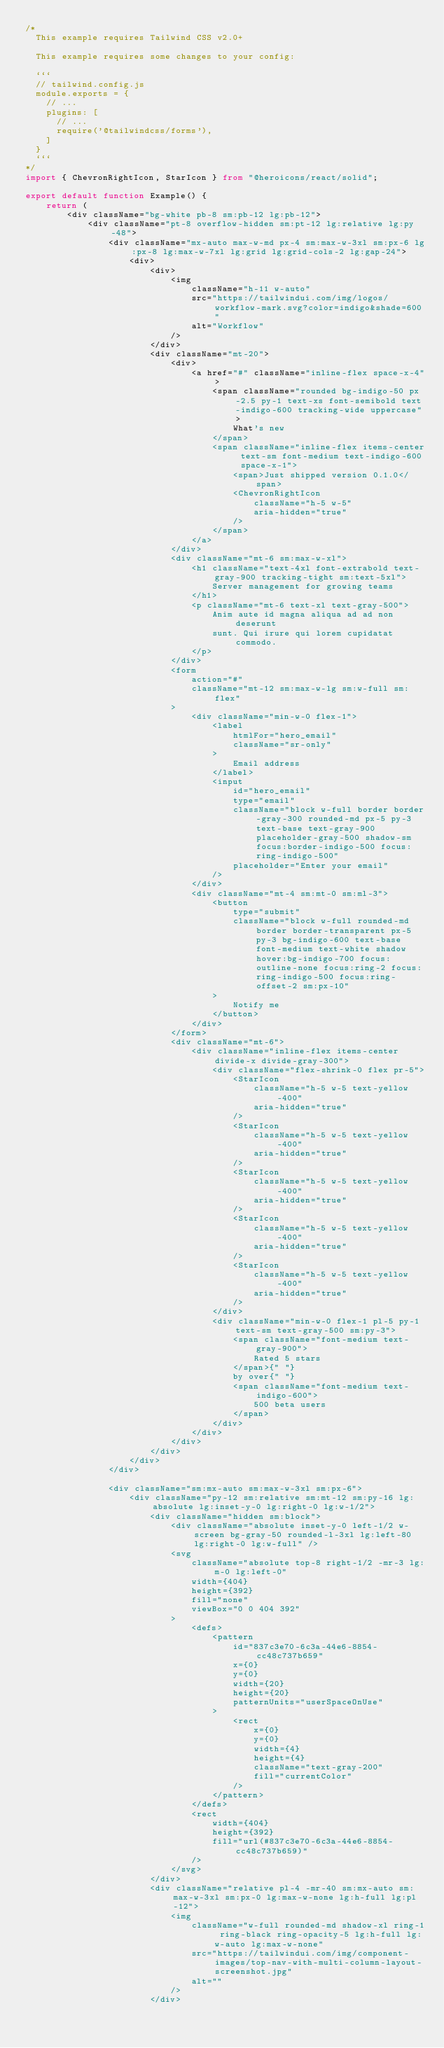Convert code to text. <code><loc_0><loc_0><loc_500><loc_500><_TypeScript_>/*
  This example requires Tailwind CSS v2.0+ 
  
  This example requires some changes to your config:
  
  ```
  // tailwind.config.js
  module.exports = {
    // ...
    plugins: [
      // ...
      require('@tailwindcss/forms'),
    ]
  }
  ```
*/
import { ChevronRightIcon, StarIcon } from "@heroicons/react/solid";

export default function Example() {
    return (
        <div className="bg-white pb-8 sm:pb-12 lg:pb-12">
            <div className="pt-8 overflow-hidden sm:pt-12 lg:relative lg:py-48">
                <div className="mx-auto max-w-md px-4 sm:max-w-3xl sm:px-6 lg:px-8 lg:max-w-7xl lg:grid lg:grid-cols-2 lg:gap-24">
                    <div>
                        <div>
                            <img
                                className="h-11 w-auto"
                                src="https://tailwindui.com/img/logos/workflow-mark.svg?color=indigo&shade=600"
                                alt="Workflow"
                            />
                        </div>
                        <div className="mt-20">
                            <div>
                                <a href="#" className="inline-flex space-x-4">
                                    <span className="rounded bg-indigo-50 px-2.5 py-1 text-xs font-semibold text-indigo-600 tracking-wide uppercase">
                                        What's new
                                    </span>
                                    <span className="inline-flex items-center text-sm font-medium text-indigo-600 space-x-1">
                                        <span>Just shipped version 0.1.0</span>
                                        <ChevronRightIcon
                                            className="h-5 w-5"
                                            aria-hidden="true"
                                        />
                                    </span>
                                </a>
                            </div>
                            <div className="mt-6 sm:max-w-xl">
                                <h1 className="text-4xl font-extrabold text-gray-900 tracking-tight sm:text-5xl">
                                    Server management for growing teams
                                </h1>
                                <p className="mt-6 text-xl text-gray-500">
                                    Anim aute id magna aliqua ad ad non deserunt
                                    sunt. Qui irure qui lorem cupidatat commodo.
                                </p>
                            </div>
                            <form
                                action="#"
                                className="mt-12 sm:max-w-lg sm:w-full sm:flex"
                            >
                                <div className="min-w-0 flex-1">
                                    <label
                                        htmlFor="hero_email"
                                        className="sr-only"
                                    >
                                        Email address
                                    </label>
                                    <input
                                        id="hero_email"
                                        type="email"
                                        className="block w-full border border-gray-300 rounded-md px-5 py-3 text-base text-gray-900 placeholder-gray-500 shadow-sm focus:border-indigo-500 focus:ring-indigo-500"
                                        placeholder="Enter your email"
                                    />
                                </div>
                                <div className="mt-4 sm:mt-0 sm:ml-3">
                                    <button
                                        type="submit"
                                        className="block w-full rounded-md border border-transparent px-5 py-3 bg-indigo-600 text-base font-medium text-white shadow hover:bg-indigo-700 focus:outline-none focus:ring-2 focus:ring-indigo-500 focus:ring-offset-2 sm:px-10"
                                    >
                                        Notify me
                                    </button>
                                </div>
                            </form>
                            <div className="mt-6">
                                <div className="inline-flex items-center divide-x divide-gray-300">
                                    <div className="flex-shrink-0 flex pr-5">
                                        <StarIcon
                                            className="h-5 w-5 text-yellow-400"
                                            aria-hidden="true"
                                        />
                                        <StarIcon
                                            className="h-5 w-5 text-yellow-400"
                                            aria-hidden="true"
                                        />
                                        <StarIcon
                                            className="h-5 w-5 text-yellow-400"
                                            aria-hidden="true"
                                        />
                                        <StarIcon
                                            className="h-5 w-5 text-yellow-400"
                                            aria-hidden="true"
                                        />
                                        <StarIcon
                                            className="h-5 w-5 text-yellow-400"
                                            aria-hidden="true"
                                        />
                                    </div>
                                    <div className="min-w-0 flex-1 pl-5 py-1 text-sm text-gray-500 sm:py-3">
                                        <span className="font-medium text-gray-900">
                                            Rated 5 stars
                                        </span>{" "}
                                        by over{" "}
                                        <span className="font-medium text-indigo-600">
                                            500 beta users
                                        </span>
                                    </div>
                                </div>
                            </div>
                        </div>
                    </div>
                </div>

                <div className="sm:mx-auto sm:max-w-3xl sm:px-6">
                    <div className="py-12 sm:relative sm:mt-12 sm:py-16 lg:absolute lg:inset-y-0 lg:right-0 lg:w-1/2">
                        <div className="hidden sm:block">
                            <div className="absolute inset-y-0 left-1/2 w-screen bg-gray-50 rounded-l-3xl lg:left-80 lg:right-0 lg:w-full" />
                            <svg
                                className="absolute top-8 right-1/2 -mr-3 lg:m-0 lg:left-0"
                                width={404}
                                height={392}
                                fill="none"
                                viewBox="0 0 404 392"
                            >
                                <defs>
                                    <pattern
                                        id="837c3e70-6c3a-44e6-8854-cc48c737b659"
                                        x={0}
                                        y={0}
                                        width={20}
                                        height={20}
                                        patternUnits="userSpaceOnUse"
                                    >
                                        <rect
                                            x={0}
                                            y={0}
                                            width={4}
                                            height={4}
                                            className="text-gray-200"
                                            fill="currentColor"
                                        />
                                    </pattern>
                                </defs>
                                <rect
                                    width={404}
                                    height={392}
                                    fill="url(#837c3e70-6c3a-44e6-8854-cc48c737b659)"
                                />
                            </svg>
                        </div>
                        <div className="relative pl-4 -mr-40 sm:mx-auto sm:max-w-3xl sm:px-0 lg:max-w-none lg:h-full lg:pl-12">
                            <img
                                className="w-full rounded-md shadow-xl ring-1 ring-black ring-opacity-5 lg:h-full lg:w-auto lg:max-w-none"
                                src="https://tailwindui.com/img/component-images/top-nav-with-multi-column-layout-screenshot.jpg"
                                alt=""
                            />
                        </div></code> 